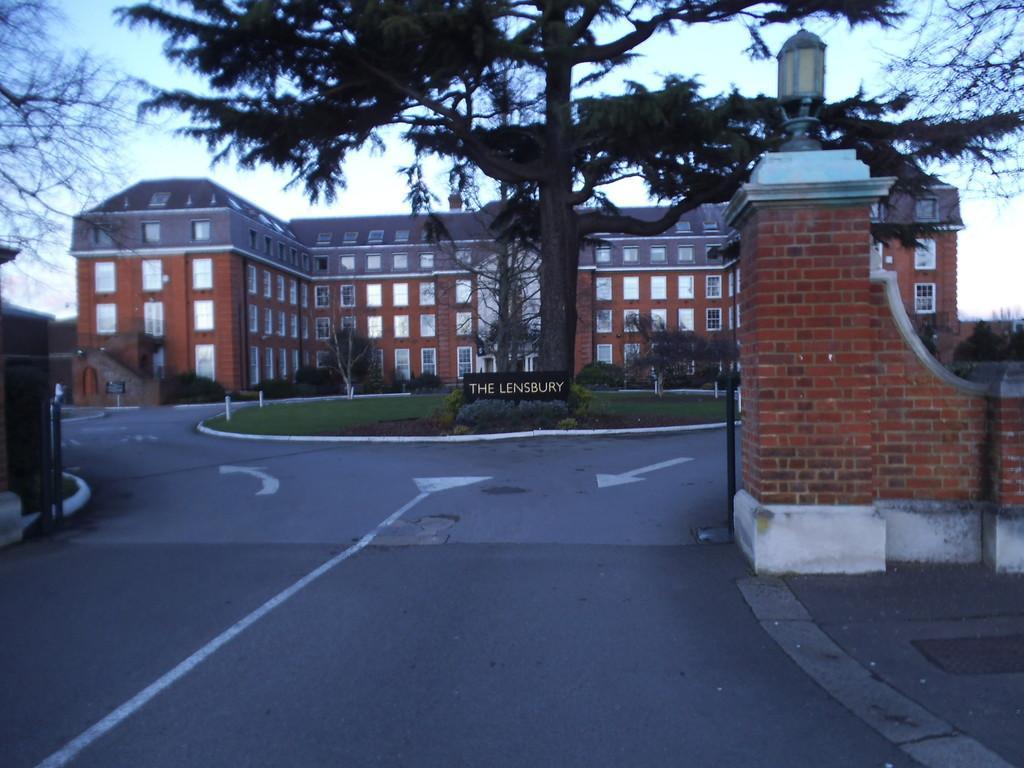Can you describe this image briefly? In this picture we can see the brown color house with glass windows. In the front we can see the boundary wall and huge tree. In the front bottom side there is a road. 